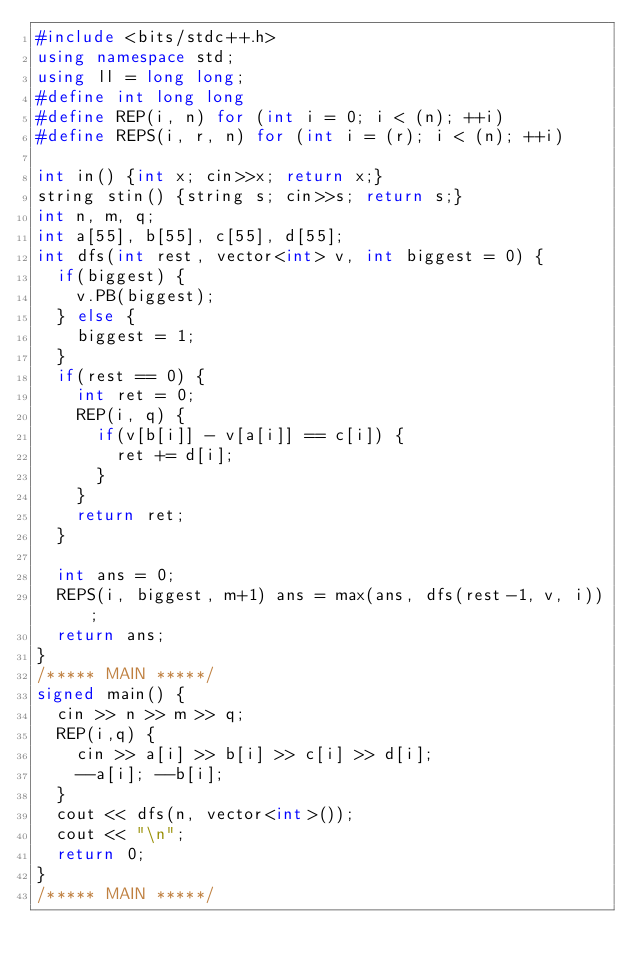Convert code to text. <code><loc_0><loc_0><loc_500><loc_500><_C++_>#include <bits/stdc++.h>
using namespace std;
using ll = long long;
#define int long long
#define REP(i, n) for (int i = 0; i < (n); ++i)
#define REPS(i, r, n) for (int i = (r); i < (n); ++i)

int in() {int x; cin>>x; return x;}
string stin() {string s; cin>>s; return s;}
int n, m, q;
int a[55], b[55], c[55], d[55];
int dfs(int rest, vector<int> v, int biggest = 0) {
  if(biggest) {
    v.PB(biggest);
  } else {
    biggest = 1;
  }
  if(rest == 0) {
    int ret = 0;
    REP(i, q) {
      if(v[b[i]] - v[a[i]] == c[i]) {
        ret += d[i];
      }
    }
    return ret;
  }

  int ans = 0;
  REPS(i, biggest, m+1) ans = max(ans, dfs(rest-1, v, i));
  return ans;
}
/***** MAIN *****/
signed main() {
  cin >> n >> m >> q;
  REP(i,q) {
    cin >> a[i] >> b[i] >> c[i] >> d[i];
    --a[i]; --b[i];
  }
  cout << dfs(n, vector<int>());
  cout << "\n";
  return 0;
}
/***** MAIN *****/
</code> 